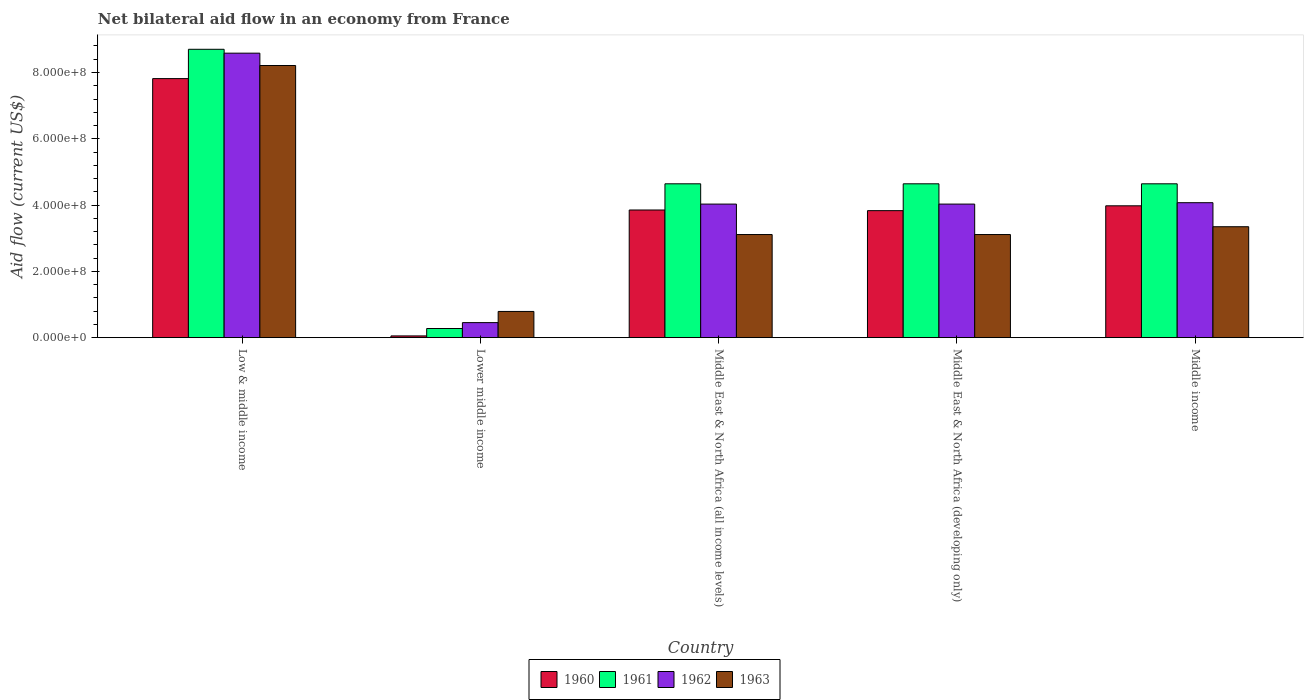How many different coloured bars are there?
Offer a terse response. 4. How many bars are there on the 5th tick from the left?
Your response must be concise. 4. In how many cases, is the number of bars for a given country not equal to the number of legend labels?
Offer a very short reply. 0. What is the net bilateral aid flow in 1962 in Middle income?
Offer a very short reply. 4.07e+08. Across all countries, what is the maximum net bilateral aid flow in 1963?
Your answer should be compact. 8.21e+08. Across all countries, what is the minimum net bilateral aid flow in 1963?
Your answer should be compact. 7.91e+07. In which country was the net bilateral aid flow in 1961 maximum?
Your answer should be compact. Low & middle income. In which country was the net bilateral aid flow in 1960 minimum?
Ensure brevity in your answer.  Lower middle income. What is the total net bilateral aid flow in 1962 in the graph?
Give a very brief answer. 2.12e+09. What is the difference between the net bilateral aid flow in 1962 in Lower middle income and the net bilateral aid flow in 1961 in Middle income?
Provide a short and direct response. -4.19e+08. What is the average net bilateral aid flow in 1961 per country?
Provide a short and direct response. 4.58e+08. What is the difference between the net bilateral aid flow of/in 1963 and net bilateral aid flow of/in 1960 in Low & middle income?
Provide a succinct answer. 3.95e+07. In how many countries, is the net bilateral aid flow in 1961 greater than 720000000 US$?
Your answer should be very brief. 1. What is the ratio of the net bilateral aid flow in 1963 in Low & middle income to that in Middle East & North Africa (all income levels)?
Keep it short and to the point. 2.64. Is the net bilateral aid flow in 1960 in Lower middle income less than that in Middle East & North Africa (all income levels)?
Keep it short and to the point. Yes. What is the difference between the highest and the second highest net bilateral aid flow in 1960?
Your answer should be very brief. 3.84e+08. What is the difference between the highest and the lowest net bilateral aid flow in 1962?
Your answer should be very brief. 8.13e+08. In how many countries, is the net bilateral aid flow in 1960 greater than the average net bilateral aid flow in 1960 taken over all countries?
Your response must be concise. 2. Is it the case that in every country, the sum of the net bilateral aid flow in 1963 and net bilateral aid flow in 1960 is greater than the sum of net bilateral aid flow in 1961 and net bilateral aid flow in 1962?
Offer a terse response. No. What does the 2nd bar from the left in Middle East & North Africa (developing only) represents?
Ensure brevity in your answer.  1961. Is it the case that in every country, the sum of the net bilateral aid flow in 1962 and net bilateral aid flow in 1961 is greater than the net bilateral aid flow in 1960?
Offer a terse response. Yes. Are all the bars in the graph horizontal?
Keep it short and to the point. No. What is the difference between two consecutive major ticks on the Y-axis?
Offer a terse response. 2.00e+08. Are the values on the major ticks of Y-axis written in scientific E-notation?
Provide a succinct answer. Yes. Does the graph contain any zero values?
Ensure brevity in your answer.  No. Does the graph contain grids?
Provide a short and direct response. No. Where does the legend appear in the graph?
Offer a very short reply. Bottom center. How many legend labels are there?
Make the answer very short. 4. How are the legend labels stacked?
Provide a short and direct response. Horizontal. What is the title of the graph?
Your response must be concise. Net bilateral aid flow in an economy from France. What is the label or title of the X-axis?
Offer a terse response. Country. What is the label or title of the Y-axis?
Offer a very short reply. Aid flow (current US$). What is the Aid flow (current US$) in 1960 in Low & middle income?
Your response must be concise. 7.82e+08. What is the Aid flow (current US$) of 1961 in Low & middle income?
Offer a terse response. 8.70e+08. What is the Aid flow (current US$) of 1962 in Low & middle income?
Offer a terse response. 8.58e+08. What is the Aid flow (current US$) of 1963 in Low & middle income?
Give a very brief answer. 8.21e+08. What is the Aid flow (current US$) of 1960 in Lower middle income?
Your response must be concise. 5.30e+06. What is the Aid flow (current US$) in 1961 in Lower middle income?
Make the answer very short. 2.76e+07. What is the Aid flow (current US$) of 1962 in Lower middle income?
Provide a succinct answer. 4.54e+07. What is the Aid flow (current US$) in 1963 in Lower middle income?
Ensure brevity in your answer.  7.91e+07. What is the Aid flow (current US$) in 1960 in Middle East & North Africa (all income levels)?
Keep it short and to the point. 3.85e+08. What is the Aid flow (current US$) in 1961 in Middle East & North Africa (all income levels)?
Offer a very short reply. 4.64e+08. What is the Aid flow (current US$) in 1962 in Middle East & North Africa (all income levels)?
Your answer should be very brief. 4.03e+08. What is the Aid flow (current US$) in 1963 in Middle East & North Africa (all income levels)?
Keep it short and to the point. 3.11e+08. What is the Aid flow (current US$) in 1960 in Middle East & North Africa (developing only)?
Provide a succinct answer. 3.83e+08. What is the Aid flow (current US$) in 1961 in Middle East & North Africa (developing only)?
Give a very brief answer. 4.64e+08. What is the Aid flow (current US$) of 1962 in Middle East & North Africa (developing only)?
Offer a terse response. 4.03e+08. What is the Aid flow (current US$) in 1963 in Middle East & North Africa (developing only)?
Give a very brief answer. 3.11e+08. What is the Aid flow (current US$) in 1960 in Middle income?
Give a very brief answer. 3.98e+08. What is the Aid flow (current US$) of 1961 in Middle income?
Provide a short and direct response. 4.64e+08. What is the Aid flow (current US$) in 1962 in Middle income?
Give a very brief answer. 4.07e+08. What is the Aid flow (current US$) of 1963 in Middle income?
Give a very brief answer. 3.35e+08. Across all countries, what is the maximum Aid flow (current US$) in 1960?
Keep it short and to the point. 7.82e+08. Across all countries, what is the maximum Aid flow (current US$) of 1961?
Provide a succinct answer. 8.70e+08. Across all countries, what is the maximum Aid flow (current US$) of 1962?
Provide a succinct answer. 8.58e+08. Across all countries, what is the maximum Aid flow (current US$) in 1963?
Provide a short and direct response. 8.21e+08. Across all countries, what is the minimum Aid flow (current US$) of 1960?
Provide a short and direct response. 5.30e+06. Across all countries, what is the minimum Aid flow (current US$) of 1961?
Your answer should be compact. 2.76e+07. Across all countries, what is the minimum Aid flow (current US$) in 1962?
Your answer should be compact. 4.54e+07. Across all countries, what is the minimum Aid flow (current US$) in 1963?
Give a very brief answer. 7.91e+07. What is the total Aid flow (current US$) of 1960 in the graph?
Your answer should be very brief. 1.95e+09. What is the total Aid flow (current US$) in 1961 in the graph?
Ensure brevity in your answer.  2.29e+09. What is the total Aid flow (current US$) in 1962 in the graph?
Make the answer very short. 2.12e+09. What is the total Aid flow (current US$) of 1963 in the graph?
Ensure brevity in your answer.  1.86e+09. What is the difference between the Aid flow (current US$) in 1960 in Low & middle income and that in Lower middle income?
Your response must be concise. 7.76e+08. What is the difference between the Aid flow (current US$) of 1961 in Low & middle income and that in Lower middle income?
Offer a very short reply. 8.42e+08. What is the difference between the Aid flow (current US$) in 1962 in Low & middle income and that in Lower middle income?
Ensure brevity in your answer.  8.13e+08. What is the difference between the Aid flow (current US$) in 1963 in Low & middle income and that in Lower middle income?
Keep it short and to the point. 7.42e+08. What is the difference between the Aid flow (current US$) in 1960 in Low & middle income and that in Middle East & North Africa (all income levels)?
Provide a short and direct response. 3.96e+08. What is the difference between the Aid flow (current US$) of 1961 in Low & middle income and that in Middle East & North Africa (all income levels)?
Offer a terse response. 4.06e+08. What is the difference between the Aid flow (current US$) of 1962 in Low & middle income and that in Middle East & North Africa (all income levels)?
Your answer should be compact. 4.55e+08. What is the difference between the Aid flow (current US$) of 1963 in Low & middle income and that in Middle East & North Africa (all income levels)?
Offer a very short reply. 5.10e+08. What is the difference between the Aid flow (current US$) of 1960 in Low & middle income and that in Middle East & North Africa (developing only)?
Ensure brevity in your answer.  3.98e+08. What is the difference between the Aid flow (current US$) in 1961 in Low & middle income and that in Middle East & North Africa (developing only)?
Your answer should be compact. 4.06e+08. What is the difference between the Aid flow (current US$) of 1962 in Low & middle income and that in Middle East & North Africa (developing only)?
Offer a terse response. 4.55e+08. What is the difference between the Aid flow (current US$) in 1963 in Low & middle income and that in Middle East & North Africa (developing only)?
Ensure brevity in your answer.  5.10e+08. What is the difference between the Aid flow (current US$) in 1960 in Low & middle income and that in Middle income?
Offer a very short reply. 3.84e+08. What is the difference between the Aid flow (current US$) in 1961 in Low & middle income and that in Middle income?
Offer a very short reply. 4.06e+08. What is the difference between the Aid flow (current US$) in 1962 in Low & middle income and that in Middle income?
Offer a terse response. 4.51e+08. What is the difference between the Aid flow (current US$) in 1963 in Low & middle income and that in Middle income?
Your answer should be compact. 4.86e+08. What is the difference between the Aid flow (current US$) of 1960 in Lower middle income and that in Middle East & North Africa (all income levels)?
Keep it short and to the point. -3.80e+08. What is the difference between the Aid flow (current US$) of 1961 in Lower middle income and that in Middle East & North Africa (all income levels)?
Provide a succinct answer. -4.37e+08. What is the difference between the Aid flow (current US$) of 1962 in Lower middle income and that in Middle East & North Africa (all income levels)?
Ensure brevity in your answer.  -3.58e+08. What is the difference between the Aid flow (current US$) in 1963 in Lower middle income and that in Middle East & North Africa (all income levels)?
Your answer should be compact. -2.32e+08. What is the difference between the Aid flow (current US$) of 1960 in Lower middle income and that in Middle East & North Africa (developing only)?
Your answer should be very brief. -3.78e+08. What is the difference between the Aid flow (current US$) in 1961 in Lower middle income and that in Middle East & North Africa (developing only)?
Make the answer very short. -4.37e+08. What is the difference between the Aid flow (current US$) of 1962 in Lower middle income and that in Middle East & North Africa (developing only)?
Keep it short and to the point. -3.58e+08. What is the difference between the Aid flow (current US$) in 1963 in Lower middle income and that in Middle East & North Africa (developing only)?
Your answer should be very brief. -2.32e+08. What is the difference between the Aid flow (current US$) in 1960 in Lower middle income and that in Middle income?
Offer a terse response. -3.92e+08. What is the difference between the Aid flow (current US$) in 1961 in Lower middle income and that in Middle income?
Ensure brevity in your answer.  -4.37e+08. What is the difference between the Aid flow (current US$) in 1962 in Lower middle income and that in Middle income?
Offer a terse response. -3.62e+08. What is the difference between the Aid flow (current US$) in 1963 in Lower middle income and that in Middle income?
Ensure brevity in your answer.  -2.56e+08. What is the difference between the Aid flow (current US$) in 1962 in Middle East & North Africa (all income levels) and that in Middle East & North Africa (developing only)?
Provide a succinct answer. 0. What is the difference between the Aid flow (current US$) of 1960 in Middle East & North Africa (all income levels) and that in Middle income?
Provide a succinct answer. -1.26e+07. What is the difference between the Aid flow (current US$) of 1962 in Middle East & North Africa (all income levels) and that in Middle income?
Your answer should be very brief. -4.20e+06. What is the difference between the Aid flow (current US$) in 1963 in Middle East & North Africa (all income levels) and that in Middle income?
Ensure brevity in your answer.  -2.36e+07. What is the difference between the Aid flow (current US$) of 1960 in Middle East & North Africa (developing only) and that in Middle income?
Offer a terse response. -1.46e+07. What is the difference between the Aid flow (current US$) in 1962 in Middle East & North Africa (developing only) and that in Middle income?
Offer a terse response. -4.20e+06. What is the difference between the Aid flow (current US$) in 1963 in Middle East & North Africa (developing only) and that in Middle income?
Give a very brief answer. -2.36e+07. What is the difference between the Aid flow (current US$) in 1960 in Low & middle income and the Aid flow (current US$) in 1961 in Lower middle income?
Ensure brevity in your answer.  7.54e+08. What is the difference between the Aid flow (current US$) of 1960 in Low & middle income and the Aid flow (current US$) of 1962 in Lower middle income?
Offer a very short reply. 7.36e+08. What is the difference between the Aid flow (current US$) of 1960 in Low & middle income and the Aid flow (current US$) of 1963 in Lower middle income?
Give a very brief answer. 7.02e+08. What is the difference between the Aid flow (current US$) of 1961 in Low & middle income and the Aid flow (current US$) of 1962 in Lower middle income?
Keep it short and to the point. 8.25e+08. What is the difference between the Aid flow (current US$) of 1961 in Low & middle income and the Aid flow (current US$) of 1963 in Lower middle income?
Provide a succinct answer. 7.91e+08. What is the difference between the Aid flow (current US$) in 1962 in Low & middle income and the Aid flow (current US$) in 1963 in Lower middle income?
Ensure brevity in your answer.  7.79e+08. What is the difference between the Aid flow (current US$) in 1960 in Low & middle income and the Aid flow (current US$) in 1961 in Middle East & North Africa (all income levels)?
Keep it short and to the point. 3.17e+08. What is the difference between the Aid flow (current US$) of 1960 in Low & middle income and the Aid flow (current US$) of 1962 in Middle East & North Africa (all income levels)?
Offer a very short reply. 3.79e+08. What is the difference between the Aid flow (current US$) of 1960 in Low & middle income and the Aid flow (current US$) of 1963 in Middle East & North Africa (all income levels)?
Ensure brevity in your answer.  4.70e+08. What is the difference between the Aid flow (current US$) of 1961 in Low & middle income and the Aid flow (current US$) of 1962 in Middle East & North Africa (all income levels)?
Your response must be concise. 4.67e+08. What is the difference between the Aid flow (current US$) in 1961 in Low & middle income and the Aid flow (current US$) in 1963 in Middle East & North Africa (all income levels)?
Keep it short and to the point. 5.59e+08. What is the difference between the Aid flow (current US$) in 1962 in Low & middle income and the Aid flow (current US$) in 1963 in Middle East & North Africa (all income levels)?
Keep it short and to the point. 5.47e+08. What is the difference between the Aid flow (current US$) in 1960 in Low & middle income and the Aid flow (current US$) in 1961 in Middle East & North Africa (developing only)?
Your answer should be compact. 3.17e+08. What is the difference between the Aid flow (current US$) of 1960 in Low & middle income and the Aid flow (current US$) of 1962 in Middle East & North Africa (developing only)?
Make the answer very short. 3.79e+08. What is the difference between the Aid flow (current US$) in 1960 in Low & middle income and the Aid flow (current US$) in 1963 in Middle East & North Africa (developing only)?
Provide a short and direct response. 4.70e+08. What is the difference between the Aid flow (current US$) in 1961 in Low & middle income and the Aid flow (current US$) in 1962 in Middle East & North Africa (developing only)?
Keep it short and to the point. 4.67e+08. What is the difference between the Aid flow (current US$) of 1961 in Low & middle income and the Aid flow (current US$) of 1963 in Middle East & North Africa (developing only)?
Your answer should be compact. 5.59e+08. What is the difference between the Aid flow (current US$) of 1962 in Low & middle income and the Aid flow (current US$) of 1963 in Middle East & North Africa (developing only)?
Give a very brief answer. 5.47e+08. What is the difference between the Aid flow (current US$) in 1960 in Low & middle income and the Aid flow (current US$) in 1961 in Middle income?
Provide a short and direct response. 3.17e+08. What is the difference between the Aid flow (current US$) in 1960 in Low & middle income and the Aid flow (current US$) in 1962 in Middle income?
Keep it short and to the point. 3.74e+08. What is the difference between the Aid flow (current US$) of 1960 in Low & middle income and the Aid flow (current US$) of 1963 in Middle income?
Ensure brevity in your answer.  4.47e+08. What is the difference between the Aid flow (current US$) in 1961 in Low & middle income and the Aid flow (current US$) in 1962 in Middle income?
Your answer should be very brief. 4.63e+08. What is the difference between the Aid flow (current US$) in 1961 in Low & middle income and the Aid flow (current US$) in 1963 in Middle income?
Your answer should be compact. 5.35e+08. What is the difference between the Aid flow (current US$) in 1962 in Low & middle income and the Aid flow (current US$) in 1963 in Middle income?
Ensure brevity in your answer.  5.24e+08. What is the difference between the Aid flow (current US$) in 1960 in Lower middle income and the Aid flow (current US$) in 1961 in Middle East & North Africa (all income levels)?
Provide a short and direct response. -4.59e+08. What is the difference between the Aid flow (current US$) of 1960 in Lower middle income and the Aid flow (current US$) of 1962 in Middle East & North Africa (all income levels)?
Make the answer very short. -3.98e+08. What is the difference between the Aid flow (current US$) of 1960 in Lower middle income and the Aid flow (current US$) of 1963 in Middle East & North Africa (all income levels)?
Your answer should be compact. -3.06e+08. What is the difference between the Aid flow (current US$) in 1961 in Lower middle income and the Aid flow (current US$) in 1962 in Middle East & North Africa (all income levels)?
Ensure brevity in your answer.  -3.75e+08. What is the difference between the Aid flow (current US$) of 1961 in Lower middle income and the Aid flow (current US$) of 1963 in Middle East & North Africa (all income levels)?
Give a very brief answer. -2.84e+08. What is the difference between the Aid flow (current US$) in 1962 in Lower middle income and the Aid flow (current US$) in 1963 in Middle East & North Africa (all income levels)?
Your answer should be compact. -2.66e+08. What is the difference between the Aid flow (current US$) in 1960 in Lower middle income and the Aid flow (current US$) in 1961 in Middle East & North Africa (developing only)?
Your answer should be very brief. -4.59e+08. What is the difference between the Aid flow (current US$) in 1960 in Lower middle income and the Aid flow (current US$) in 1962 in Middle East & North Africa (developing only)?
Provide a short and direct response. -3.98e+08. What is the difference between the Aid flow (current US$) of 1960 in Lower middle income and the Aid flow (current US$) of 1963 in Middle East & North Africa (developing only)?
Your answer should be compact. -3.06e+08. What is the difference between the Aid flow (current US$) in 1961 in Lower middle income and the Aid flow (current US$) in 1962 in Middle East & North Africa (developing only)?
Make the answer very short. -3.75e+08. What is the difference between the Aid flow (current US$) of 1961 in Lower middle income and the Aid flow (current US$) of 1963 in Middle East & North Africa (developing only)?
Provide a short and direct response. -2.84e+08. What is the difference between the Aid flow (current US$) of 1962 in Lower middle income and the Aid flow (current US$) of 1963 in Middle East & North Africa (developing only)?
Your answer should be very brief. -2.66e+08. What is the difference between the Aid flow (current US$) in 1960 in Lower middle income and the Aid flow (current US$) in 1961 in Middle income?
Keep it short and to the point. -4.59e+08. What is the difference between the Aid flow (current US$) in 1960 in Lower middle income and the Aid flow (current US$) in 1962 in Middle income?
Provide a succinct answer. -4.02e+08. What is the difference between the Aid flow (current US$) in 1960 in Lower middle income and the Aid flow (current US$) in 1963 in Middle income?
Offer a terse response. -3.29e+08. What is the difference between the Aid flow (current US$) of 1961 in Lower middle income and the Aid flow (current US$) of 1962 in Middle income?
Offer a terse response. -3.80e+08. What is the difference between the Aid flow (current US$) of 1961 in Lower middle income and the Aid flow (current US$) of 1963 in Middle income?
Your response must be concise. -3.07e+08. What is the difference between the Aid flow (current US$) of 1962 in Lower middle income and the Aid flow (current US$) of 1963 in Middle income?
Offer a very short reply. -2.89e+08. What is the difference between the Aid flow (current US$) in 1960 in Middle East & North Africa (all income levels) and the Aid flow (current US$) in 1961 in Middle East & North Africa (developing only)?
Provide a short and direct response. -7.90e+07. What is the difference between the Aid flow (current US$) in 1960 in Middle East & North Africa (all income levels) and the Aid flow (current US$) in 1962 in Middle East & North Africa (developing only)?
Offer a very short reply. -1.78e+07. What is the difference between the Aid flow (current US$) in 1960 in Middle East & North Africa (all income levels) and the Aid flow (current US$) in 1963 in Middle East & North Africa (developing only)?
Provide a succinct answer. 7.41e+07. What is the difference between the Aid flow (current US$) of 1961 in Middle East & North Africa (all income levels) and the Aid flow (current US$) of 1962 in Middle East & North Africa (developing only)?
Offer a terse response. 6.12e+07. What is the difference between the Aid flow (current US$) in 1961 in Middle East & North Africa (all income levels) and the Aid flow (current US$) in 1963 in Middle East & North Africa (developing only)?
Keep it short and to the point. 1.53e+08. What is the difference between the Aid flow (current US$) in 1962 in Middle East & North Africa (all income levels) and the Aid flow (current US$) in 1963 in Middle East & North Africa (developing only)?
Your answer should be very brief. 9.19e+07. What is the difference between the Aid flow (current US$) in 1960 in Middle East & North Africa (all income levels) and the Aid flow (current US$) in 1961 in Middle income?
Your answer should be very brief. -7.90e+07. What is the difference between the Aid flow (current US$) in 1960 in Middle East & North Africa (all income levels) and the Aid flow (current US$) in 1962 in Middle income?
Provide a succinct answer. -2.20e+07. What is the difference between the Aid flow (current US$) in 1960 in Middle East & North Africa (all income levels) and the Aid flow (current US$) in 1963 in Middle income?
Your answer should be very brief. 5.05e+07. What is the difference between the Aid flow (current US$) of 1961 in Middle East & North Africa (all income levels) and the Aid flow (current US$) of 1962 in Middle income?
Provide a short and direct response. 5.70e+07. What is the difference between the Aid flow (current US$) in 1961 in Middle East & North Africa (all income levels) and the Aid flow (current US$) in 1963 in Middle income?
Provide a short and direct response. 1.30e+08. What is the difference between the Aid flow (current US$) in 1962 in Middle East & North Africa (all income levels) and the Aid flow (current US$) in 1963 in Middle income?
Your answer should be compact. 6.83e+07. What is the difference between the Aid flow (current US$) in 1960 in Middle East & North Africa (developing only) and the Aid flow (current US$) in 1961 in Middle income?
Ensure brevity in your answer.  -8.10e+07. What is the difference between the Aid flow (current US$) of 1960 in Middle East & North Africa (developing only) and the Aid flow (current US$) of 1962 in Middle income?
Give a very brief answer. -2.40e+07. What is the difference between the Aid flow (current US$) in 1960 in Middle East & North Africa (developing only) and the Aid flow (current US$) in 1963 in Middle income?
Provide a short and direct response. 4.85e+07. What is the difference between the Aid flow (current US$) in 1961 in Middle East & North Africa (developing only) and the Aid flow (current US$) in 1962 in Middle income?
Keep it short and to the point. 5.70e+07. What is the difference between the Aid flow (current US$) in 1961 in Middle East & North Africa (developing only) and the Aid flow (current US$) in 1963 in Middle income?
Offer a very short reply. 1.30e+08. What is the difference between the Aid flow (current US$) of 1962 in Middle East & North Africa (developing only) and the Aid flow (current US$) of 1963 in Middle income?
Your response must be concise. 6.83e+07. What is the average Aid flow (current US$) in 1960 per country?
Provide a short and direct response. 3.91e+08. What is the average Aid flow (current US$) in 1961 per country?
Provide a succinct answer. 4.58e+08. What is the average Aid flow (current US$) of 1962 per country?
Provide a short and direct response. 4.23e+08. What is the average Aid flow (current US$) of 1963 per country?
Make the answer very short. 3.71e+08. What is the difference between the Aid flow (current US$) of 1960 and Aid flow (current US$) of 1961 in Low & middle income?
Ensure brevity in your answer.  -8.84e+07. What is the difference between the Aid flow (current US$) in 1960 and Aid flow (current US$) in 1962 in Low & middle income?
Ensure brevity in your answer.  -7.67e+07. What is the difference between the Aid flow (current US$) in 1960 and Aid flow (current US$) in 1963 in Low & middle income?
Provide a succinct answer. -3.95e+07. What is the difference between the Aid flow (current US$) in 1961 and Aid flow (current US$) in 1962 in Low & middle income?
Your answer should be compact. 1.17e+07. What is the difference between the Aid flow (current US$) in 1961 and Aid flow (current US$) in 1963 in Low & middle income?
Make the answer very short. 4.89e+07. What is the difference between the Aid flow (current US$) of 1962 and Aid flow (current US$) of 1963 in Low & middle income?
Provide a short and direct response. 3.72e+07. What is the difference between the Aid flow (current US$) of 1960 and Aid flow (current US$) of 1961 in Lower middle income?
Your answer should be compact. -2.23e+07. What is the difference between the Aid flow (current US$) of 1960 and Aid flow (current US$) of 1962 in Lower middle income?
Keep it short and to the point. -4.01e+07. What is the difference between the Aid flow (current US$) of 1960 and Aid flow (current US$) of 1963 in Lower middle income?
Give a very brief answer. -7.38e+07. What is the difference between the Aid flow (current US$) in 1961 and Aid flow (current US$) in 1962 in Lower middle income?
Provide a succinct answer. -1.78e+07. What is the difference between the Aid flow (current US$) of 1961 and Aid flow (current US$) of 1963 in Lower middle income?
Make the answer very short. -5.15e+07. What is the difference between the Aid flow (current US$) of 1962 and Aid flow (current US$) of 1963 in Lower middle income?
Offer a very short reply. -3.37e+07. What is the difference between the Aid flow (current US$) of 1960 and Aid flow (current US$) of 1961 in Middle East & North Africa (all income levels)?
Provide a succinct answer. -7.90e+07. What is the difference between the Aid flow (current US$) of 1960 and Aid flow (current US$) of 1962 in Middle East & North Africa (all income levels)?
Make the answer very short. -1.78e+07. What is the difference between the Aid flow (current US$) of 1960 and Aid flow (current US$) of 1963 in Middle East & North Africa (all income levels)?
Offer a very short reply. 7.41e+07. What is the difference between the Aid flow (current US$) in 1961 and Aid flow (current US$) in 1962 in Middle East & North Africa (all income levels)?
Give a very brief answer. 6.12e+07. What is the difference between the Aid flow (current US$) in 1961 and Aid flow (current US$) in 1963 in Middle East & North Africa (all income levels)?
Your response must be concise. 1.53e+08. What is the difference between the Aid flow (current US$) of 1962 and Aid flow (current US$) of 1963 in Middle East & North Africa (all income levels)?
Keep it short and to the point. 9.19e+07. What is the difference between the Aid flow (current US$) in 1960 and Aid flow (current US$) in 1961 in Middle East & North Africa (developing only)?
Offer a very short reply. -8.10e+07. What is the difference between the Aid flow (current US$) in 1960 and Aid flow (current US$) in 1962 in Middle East & North Africa (developing only)?
Ensure brevity in your answer.  -1.98e+07. What is the difference between the Aid flow (current US$) of 1960 and Aid flow (current US$) of 1963 in Middle East & North Africa (developing only)?
Ensure brevity in your answer.  7.21e+07. What is the difference between the Aid flow (current US$) in 1961 and Aid flow (current US$) in 1962 in Middle East & North Africa (developing only)?
Your answer should be compact. 6.12e+07. What is the difference between the Aid flow (current US$) in 1961 and Aid flow (current US$) in 1963 in Middle East & North Africa (developing only)?
Give a very brief answer. 1.53e+08. What is the difference between the Aid flow (current US$) of 1962 and Aid flow (current US$) of 1963 in Middle East & North Africa (developing only)?
Keep it short and to the point. 9.19e+07. What is the difference between the Aid flow (current US$) in 1960 and Aid flow (current US$) in 1961 in Middle income?
Ensure brevity in your answer.  -6.64e+07. What is the difference between the Aid flow (current US$) of 1960 and Aid flow (current US$) of 1962 in Middle income?
Your answer should be very brief. -9.40e+06. What is the difference between the Aid flow (current US$) of 1960 and Aid flow (current US$) of 1963 in Middle income?
Your answer should be very brief. 6.31e+07. What is the difference between the Aid flow (current US$) of 1961 and Aid flow (current US$) of 1962 in Middle income?
Keep it short and to the point. 5.70e+07. What is the difference between the Aid flow (current US$) of 1961 and Aid flow (current US$) of 1963 in Middle income?
Offer a very short reply. 1.30e+08. What is the difference between the Aid flow (current US$) in 1962 and Aid flow (current US$) in 1963 in Middle income?
Ensure brevity in your answer.  7.25e+07. What is the ratio of the Aid flow (current US$) of 1960 in Low & middle income to that in Lower middle income?
Provide a succinct answer. 147.47. What is the ratio of the Aid flow (current US$) in 1961 in Low & middle income to that in Lower middle income?
Make the answer very short. 31.52. What is the ratio of the Aid flow (current US$) of 1962 in Low & middle income to that in Lower middle income?
Give a very brief answer. 18.91. What is the ratio of the Aid flow (current US$) of 1963 in Low & middle income to that in Lower middle income?
Offer a very short reply. 10.38. What is the ratio of the Aid flow (current US$) of 1960 in Low & middle income to that in Middle East & North Africa (all income levels)?
Your answer should be very brief. 2.03. What is the ratio of the Aid flow (current US$) of 1961 in Low & middle income to that in Middle East & North Africa (all income levels)?
Keep it short and to the point. 1.87. What is the ratio of the Aid flow (current US$) of 1962 in Low & middle income to that in Middle East & North Africa (all income levels)?
Keep it short and to the point. 2.13. What is the ratio of the Aid flow (current US$) in 1963 in Low & middle income to that in Middle East & North Africa (all income levels)?
Provide a short and direct response. 2.64. What is the ratio of the Aid flow (current US$) of 1960 in Low & middle income to that in Middle East & North Africa (developing only)?
Ensure brevity in your answer.  2.04. What is the ratio of the Aid flow (current US$) of 1961 in Low & middle income to that in Middle East & North Africa (developing only)?
Offer a terse response. 1.87. What is the ratio of the Aid flow (current US$) of 1962 in Low & middle income to that in Middle East & North Africa (developing only)?
Keep it short and to the point. 2.13. What is the ratio of the Aid flow (current US$) of 1963 in Low & middle income to that in Middle East & North Africa (developing only)?
Ensure brevity in your answer.  2.64. What is the ratio of the Aid flow (current US$) of 1960 in Low & middle income to that in Middle income?
Your answer should be compact. 1.96. What is the ratio of the Aid flow (current US$) in 1961 in Low & middle income to that in Middle income?
Your answer should be very brief. 1.87. What is the ratio of the Aid flow (current US$) in 1962 in Low & middle income to that in Middle income?
Offer a very short reply. 2.11. What is the ratio of the Aid flow (current US$) of 1963 in Low & middle income to that in Middle income?
Offer a very short reply. 2.45. What is the ratio of the Aid flow (current US$) in 1960 in Lower middle income to that in Middle East & North Africa (all income levels)?
Your answer should be very brief. 0.01. What is the ratio of the Aid flow (current US$) of 1961 in Lower middle income to that in Middle East & North Africa (all income levels)?
Ensure brevity in your answer.  0.06. What is the ratio of the Aid flow (current US$) of 1962 in Lower middle income to that in Middle East & North Africa (all income levels)?
Provide a short and direct response. 0.11. What is the ratio of the Aid flow (current US$) of 1963 in Lower middle income to that in Middle East & North Africa (all income levels)?
Your response must be concise. 0.25. What is the ratio of the Aid flow (current US$) in 1960 in Lower middle income to that in Middle East & North Africa (developing only)?
Make the answer very short. 0.01. What is the ratio of the Aid flow (current US$) of 1961 in Lower middle income to that in Middle East & North Africa (developing only)?
Provide a succinct answer. 0.06. What is the ratio of the Aid flow (current US$) in 1962 in Lower middle income to that in Middle East & North Africa (developing only)?
Your response must be concise. 0.11. What is the ratio of the Aid flow (current US$) of 1963 in Lower middle income to that in Middle East & North Africa (developing only)?
Offer a very short reply. 0.25. What is the ratio of the Aid flow (current US$) of 1960 in Lower middle income to that in Middle income?
Make the answer very short. 0.01. What is the ratio of the Aid flow (current US$) of 1961 in Lower middle income to that in Middle income?
Your response must be concise. 0.06. What is the ratio of the Aid flow (current US$) in 1962 in Lower middle income to that in Middle income?
Give a very brief answer. 0.11. What is the ratio of the Aid flow (current US$) of 1963 in Lower middle income to that in Middle income?
Provide a short and direct response. 0.24. What is the ratio of the Aid flow (current US$) in 1960 in Middle East & North Africa (all income levels) to that in Middle East & North Africa (developing only)?
Give a very brief answer. 1.01. What is the ratio of the Aid flow (current US$) in 1963 in Middle East & North Africa (all income levels) to that in Middle East & North Africa (developing only)?
Provide a short and direct response. 1. What is the ratio of the Aid flow (current US$) in 1960 in Middle East & North Africa (all income levels) to that in Middle income?
Your response must be concise. 0.97. What is the ratio of the Aid flow (current US$) in 1961 in Middle East & North Africa (all income levels) to that in Middle income?
Your answer should be very brief. 1. What is the ratio of the Aid flow (current US$) of 1962 in Middle East & North Africa (all income levels) to that in Middle income?
Ensure brevity in your answer.  0.99. What is the ratio of the Aid flow (current US$) in 1963 in Middle East & North Africa (all income levels) to that in Middle income?
Your response must be concise. 0.93. What is the ratio of the Aid flow (current US$) of 1960 in Middle East & North Africa (developing only) to that in Middle income?
Make the answer very short. 0.96. What is the ratio of the Aid flow (current US$) in 1961 in Middle East & North Africa (developing only) to that in Middle income?
Offer a terse response. 1. What is the ratio of the Aid flow (current US$) in 1962 in Middle East & North Africa (developing only) to that in Middle income?
Ensure brevity in your answer.  0.99. What is the ratio of the Aid flow (current US$) in 1963 in Middle East & North Africa (developing only) to that in Middle income?
Provide a short and direct response. 0.93. What is the difference between the highest and the second highest Aid flow (current US$) in 1960?
Keep it short and to the point. 3.84e+08. What is the difference between the highest and the second highest Aid flow (current US$) of 1961?
Keep it short and to the point. 4.06e+08. What is the difference between the highest and the second highest Aid flow (current US$) of 1962?
Your answer should be compact. 4.51e+08. What is the difference between the highest and the second highest Aid flow (current US$) of 1963?
Provide a short and direct response. 4.86e+08. What is the difference between the highest and the lowest Aid flow (current US$) in 1960?
Keep it short and to the point. 7.76e+08. What is the difference between the highest and the lowest Aid flow (current US$) in 1961?
Your response must be concise. 8.42e+08. What is the difference between the highest and the lowest Aid flow (current US$) in 1962?
Offer a very short reply. 8.13e+08. What is the difference between the highest and the lowest Aid flow (current US$) in 1963?
Offer a terse response. 7.42e+08. 